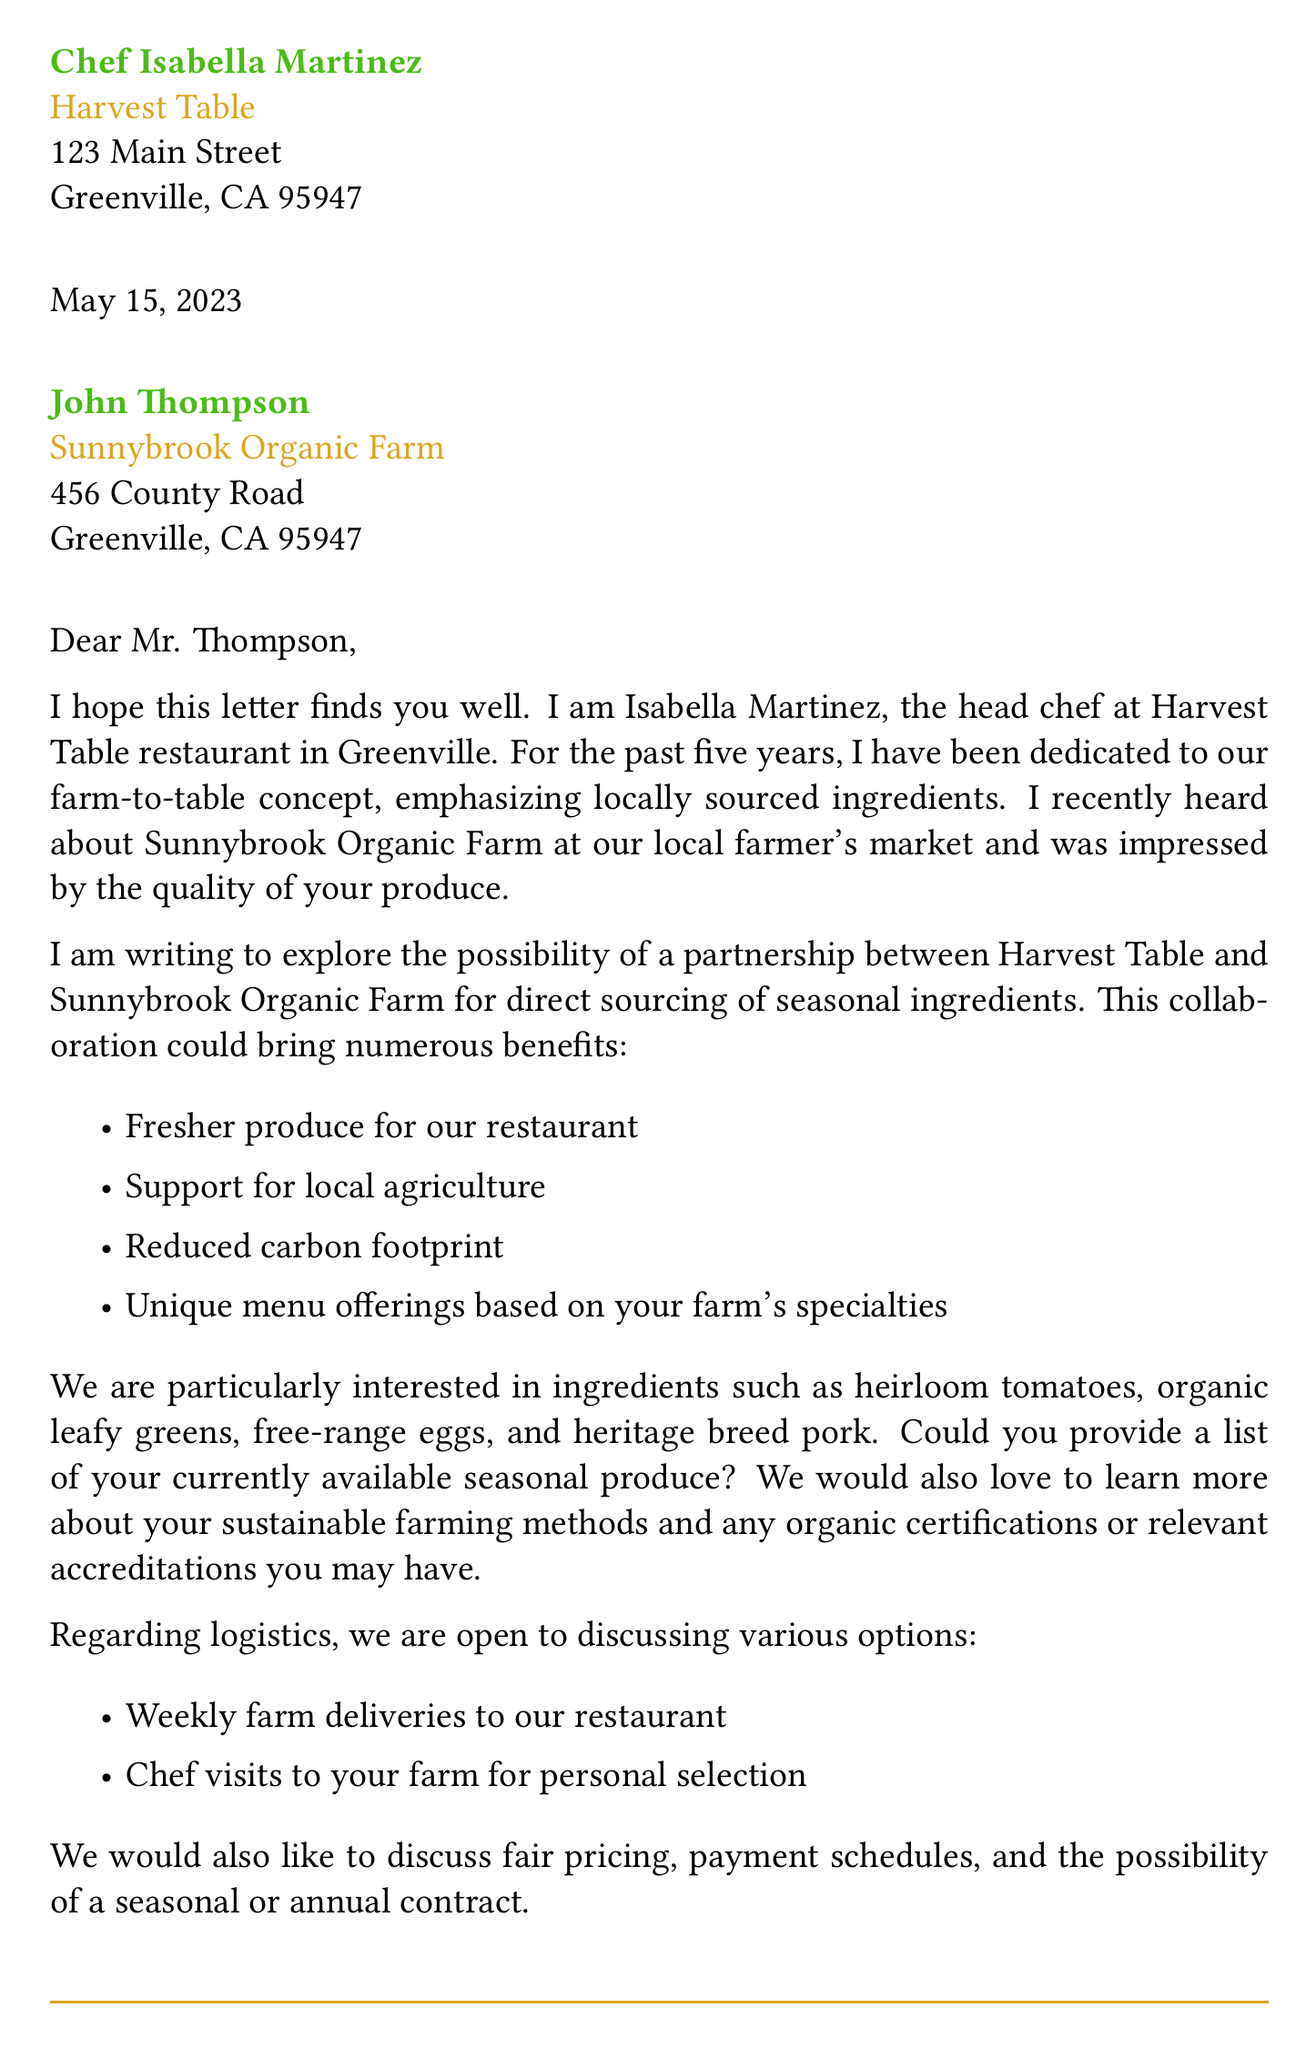What is the name of the chef? The letter refers to the chef as Isabella Martinez.
Answer: Isabella Martinez What is the address of Harvest Table? The letter states the restaurant's address as 123 Main Street, Greenville, CA 95947.
Answer: 123 Main Street, Greenville, CA 95947 What proposal is made in the letter? The main proposal is for direct sourcing of seasonal ingredients from the farm.
Answer: Direct sourcing of seasonal ingredients What are two potential ingredients mentioned? The letter mentions heirloom tomatoes and free-range eggs as potential ingredients.
Answer: Heirloom tomatoes and free-range eggs How long has Chef Isabella been at Harvest Table? The document indicates that Chef Isabella has been at Harvest Table for 5 years.
Answer: 5 years What is a logistics option discussed? The letter discusses weekly farm deliveries to the restaurant as a logistics option.
Answer: Weekly farm deliveries What potential collaboration idea involves staff? The letter suggests arranging kitchen staff tours of the farm for educational purposes.
Answer: Kitchen staff tours What is the contact number for Chef Isabella? The document provides the contact number as (530) 555-1234.
Answer: (530) 555-1234 What date is the letter dated? The letter is dated May 15, 2023.
Answer: May 15, 2023 